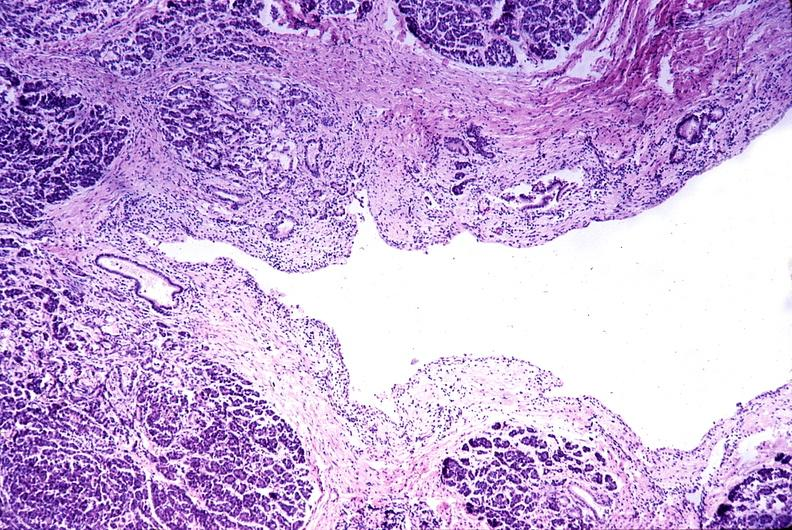does gaucher cell show chronic pancreatitis?
Answer the question using a single word or phrase. No 